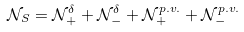Convert formula to latex. <formula><loc_0><loc_0><loc_500><loc_500>\mathcal { N } _ { S } = \mathcal { N } _ { + } ^ { \delta } + \mathcal { N } _ { - } ^ { \delta } + \mathcal { N } _ { + } ^ { p . v . } + \mathcal { N } _ { - } ^ { p . v . }</formula> 